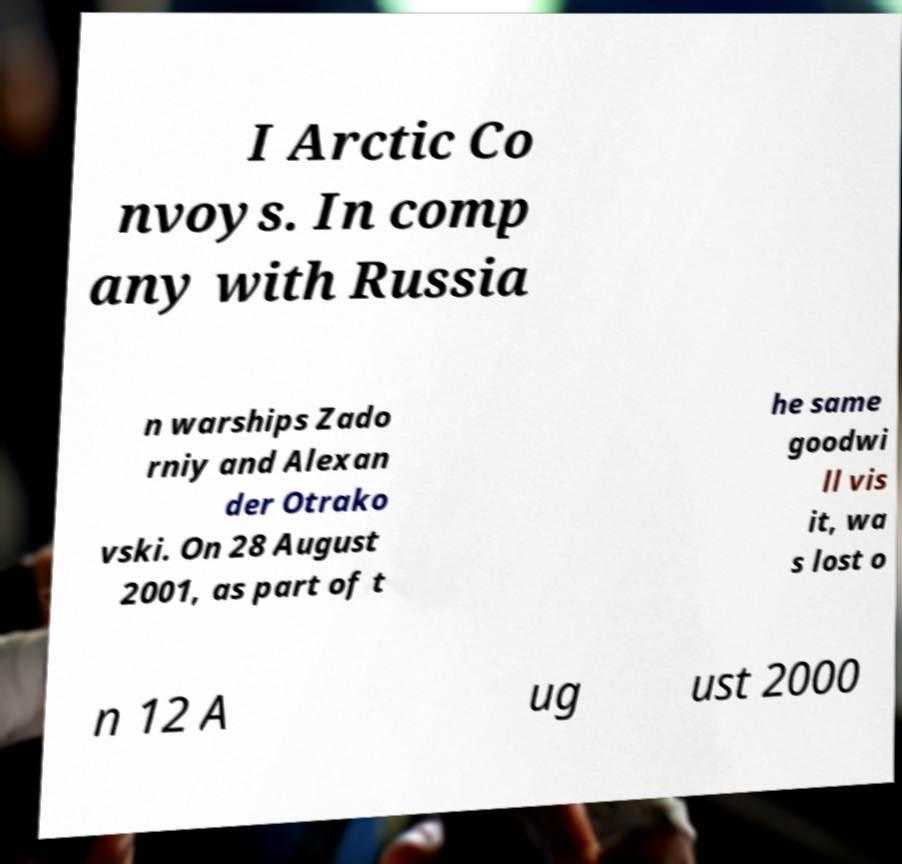Could you extract and type out the text from this image? I Arctic Co nvoys. In comp any with Russia n warships Zado rniy and Alexan der Otrako vski. On 28 August 2001, as part of t he same goodwi ll vis it, wa s lost o n 12 A ug ust 2000 